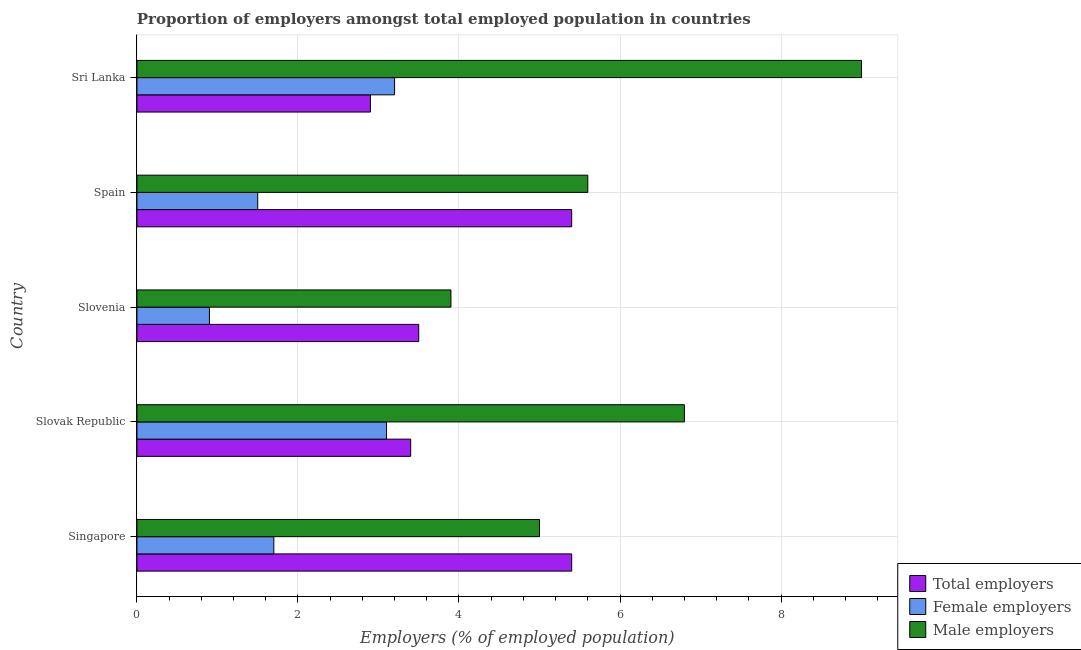How many different coloured bars are there?
Give a very brief answer. 3. Are the number of bars on each tick of the Y-axis equal?
Provide a succinct answer. Yes. How many bars are there on the 3rd tick from the bottom?
Keep it short and to the point. 3. What is the label of the 4th group of bars from the top?
Make the answer very short. Slovak Republic. Across all countries, what is the maximum percentage of total employers?
Give a very brief answer. 5.4. Across all countries, what is the minimum percentage of female employers?
Keep it short and to the point. 0.9. In which country was the percentage of female employers maximum?
Give a very brief answer. Sri Lanka. In which country was the percentage of male employers minimum?
Provide a short and direct response. Slovenia. What is the total percentage of total employers in the graph?
Provide a succinct answer. 20.6. What is the difference between the percentage of male employers in Singapore and the percentage of total employers in Spain?
Make the answer very short. -0.4. What is the average percentage of female employers per country?
Offer a terse response. 2.08. What is the difference between the percentage of total employers and percentage of female employers in Sri Lanka?
Make the answer very short. -0.3. In how many countries, is the percentage of female employers greater than 5.2 %?
Give a very brief answer. 0. Is the sum of the percentage of male employers in Singapore and Slovak Republic greater than the maximum percentage of female employers across all countries?
Your answer should be very brief. Yes. What does the 3rd bar from the top in Singapore represents?
Offer a terse response. Total employers. What does the 1st bar from the bottom in Sri Lanka represents?
Make the answer very short. Total employers. What is the difference between two consecutive major ticks on the X-axis?
Make the answer very short. 2. Where does the legend appear in the graph?
Your answer should be very brief. Bottom right. How many legend labels are there?
Make the answer very short. 3. What is the title of the graph?
Offer a very short reply. Proportion of employers amongst total employed population in countries. Does "Unpaid family workers" appear as one of the legend labels in the graph?
Ensure brevity in your answer.  No. What is the label or title of the X-axis?
Give a very brief answer. Employers (% of employed population). What is the Employers (% of employed population) of Total employers in Singapore?
Ensure brevity in your answer.  5.4. What is the Employers (% of employed population) in Female employers in Singapore?
Offer a very short reply. 1.7. What is the Employers (% of employed population) in Male employers in Singapore?
Offer a very short reply. 5. What is the Employers (% of employed population) in Total employers in Slovak Republic?
Your response must be concise. 3.4. What is the Employers (% of employed population) of Female employers in Slovak Republic?
Offer a terse response. 3.1. What is the Employers (% of employed population) of Male employers in Slovak Republic?
Provide a short and direct response. 6.8. What is the Employers (% of employed population) in Female employers in Slovenia?
Provide a short and direct response. 0.9. What is the Employers (% of employed population) of Male employers in Slovenia?
Keep it short and to the point. 3.9. What is the Employers (% of employed population) of Total employers in Spain?
Your response must be concise. 5.4. What is the Employers (% of employed population) in Male employers in Spain?
Your answer should be very brief. 5.6. What is the Employers (% of employed population) of Total employers in Sri Lanka?
Ensure brevity in your answer.  2.9. What is the Employers (% of employed population) in Female employers in Sri Lanka?
Make the answer very short. 3.2. What is the Employers (% of employed population) of Male employers in Sri Lanka?
Ensure brevity in your answer.  9. Across all countries, what is the maximum Employers (% of employed population) in Total employers?
Your answer should be compact. 5.4. Across all countries, what is the maximum Employers (% of employed population) in Female employers?
Give a very brief answer. 3.2. Across all countries, what is the maximum Employers (% of employed population) of Male employers?
Provide a short and direct response. 9. Across all countries, what is the minimum Employers (% of employed population) of Total employers?
Provide a succinct answer. 2.9. Across all countries, what is the minimum Employers (% of employed population) of Female employers?
Provide a succinct answer. 0.9. Across all countries, what is the minimum Employers (% of employed population) of Male employers?
Your answer should be compact. 3.9. What is the total Employers (% of employed population) of Total employers in the graph?
Offer a very short reply. 20.6. What is the total Employers (% of employed population) in Male employers in the graph?
Keep it short and to the point. 30.3. What is the difference between the Employers (% of employed population) of Total employers in Singapore and that in Slovenia?
Give a very brief answer. 1.9. What is the difference between the Employers (% of employed population) in Female employers in Singapore and that in Slovenia?
Offer a very short reply. 0.8. What is the difference between the Employers (% of employed population) in Male employers in Singapore and that in Slovenia?
Make the answer very short. 1.1. What is the difference between the Employers (% of employed population) of Female employers in Singapore and that in Spain?
Keep it short and to the point. 0.2. What is the difference between the Employers (% of employed population) of Total employers in Slovak Republic and that in Slovenia?
Your answer should be compact. -0.1. What is the difference between the Employers (% of employed population) in Female employers in Slovak Republic and that in Slovenia?
Ensure brevity in your answer.  2.2. What is the difference between the Employers (% of employed population) of Total employers in Slovak Republic and that in Spain?
Provide a succinct answer. -2. What is the difference between the Employers (% of employed population) of Female employers in Slovak Republic and that in Spain?
Provide a short and direct response. 1.6. What is the difference between the Employers (% of employed population) in Male employers in Slovak Republic and that in Sri Lanka?
Your answer should be very brief. -2.2. What is the difference between the Employers (% of employed population) of Total employers in Slovenia and that in Spain?
Offer a very short reply. -1.9. What is the difference between the Employers (% of employed population) in Male employers in Slovenia and that in Spain?
Your answer should be very brief. -1.7. What is the difference between the Employers (% of employed population) in Total employers in Slovenia and that in Sri Lanka?
Offer a terse response. 0.6. What is the difference between the Employers (% of employed population) in Female employers in Spain and that in Sri Lanka?
Offer a terse response. -1.7. What is the difference between the Employers (% of employed population) of Total employers in Singapore and the Employers (% of employed population) of Male employers in Slovak Republic?
Give a very brief answer. -1.4. What is the difference between the Employers (% of employed population) of Female employers in Singapore and the Employers (% of employed population) of Male employers in Slovak Republic?
Provide a short and direct response. -5.1. What is the difference between the Employers (% of employed population) of Total employers in Singapore and the Employers (% of employed population) of Female employers in Slovenia?
Provide a short and direct response. 4.5. What is the difference between the Employers (% of employed population) in Total employers in Singapore and the Employers (% of employed population) in Male employers in Slovenia?
Provide a short and direct response. 1.5. What is the difference between the Employers (% of employed population) of Female employers in Singapore and the Employers (% of employed population) of Male employers in Slovenia?
Keep it short and to the point. -2.2. What is the difference between the Employers (% of employed population) in Total employers in Singapore and the Employers (% of employed population) in Female employers in Spain?
Your answer should be compact. 3.9. What is the difference between the Employers (% of employed population) in Total employers in Singapore and the Employers (% of employed population) in Female employers in Sri Lanka?
Give a very brief answer. 2.2. What is the difference between the Employers (% of employed population) of Total employers in Slovak Republic and the Employers (% of employed population) of Male employers in Slovenia?
Offer a terse response. -0.5. What is the difference between the Employers (% of employed population) in Total employers in Slovak Republic and the Employers (% of employed population) in Male employers in Spain?
Ensure brevity in your answer.  -2.2. What is the difference between the Employers (% of employed population) of Total employers in Slovak Republic and the Employers (% of employed population) of Female employers in Sri Lanka?
Ensure brevity in your answer.  0.2. What is the difference between the Employers (% of employed population) of Total employers in Slovak Republic and the Employers (% of employed population) of Male employers in Sri Lanka?
Your answer should be compact. -5.6. What is the difference between the Employers (% of employed population) of Female employers in Slovak Republic and the Employers (% of employed population) of Male employers in Sri Lanka?
Offer a very short reply. -5.9. What is the difference between the Employers (% of employed population) of Total employers in Slovenia and the Employers (% of employed population) of Male employers in Spain?
Your answer should be compact. -2.1. What is the difference between the Employers (% of employed population) in Female employers in Slovenia and the Employers (% of employed population) in Male employers in Spain?
Your answer should be very brief. -4.7. What is the difference between the Employers (% of employed population) of Total employers in Slovenia and the Employers (% of employed population) of Female employers in Sri Lanka?
Your answer should be compact. 0.3. What is the difference between the Employers (% of employed population) of Total employers in Slovenia and the Employers (% of employed population) of Male employers in Sri Lanka?
Provide a succinct answer. -5.5. What is the difference between the Employers (% of employed population) in Total employers in Spain and the Employers (% of employed population) in Female employers in Sri Lanka?
Your response must be concise. 2.2. What is the difference between the Employers (% of employed population) in Total employers in Spain and the Employers (% of employed population) in Male employers in Sri Lanka?
Make the answer very short. -3.6. What is the average Employers (% of employed population) of Total employers per country?
Keep it short and to the point. 4.12. What is the average Employers (% of employed population) of Female employers per country?
Keep it short and to the point. 2.08. What is the average Employers (% of employed population) in Male employers per country?
Provide a short and direct response. 6.06. What is the difference between the Employers (% of employed population) of Total employers and Employers (% of employed population) of Female employers in Singapore?
Provide a succinct answer. 3.7. What is the difference between the Employers (% of employed population) of Total employers and Employers (% of employed population) of Male employers in Singapore?
Give a very brief answer. 0.4. What is the difference between the Employers (% of employed population) of Total employers and Employers (% of employed population) of Male employers in Slovak Republic?
Give a very brief answer. -3.4. What is the difference between the Employers (% of employed population) in Total employers and Employers (% of employed population) in Female employers in Slovenia?
Give a very brief answer. 2.6. What is the difference between the Employers (% of employed population) of Total employers and Employers (% of employed population) of Male employers in Slovenia?
Your answer should be compact. -0.4. What is the difference between the Employers (% of employed population) of Female employers and Employers (% of employed population) of Male employers in Slovenia?
Offer a terse response. -3. What is the difference between the Employers (% of employed population) in Total employers and Employers (% of employed population) in Male employers in Spain?
Offer a very short reply. -0.2. What is the difference between the Employers (% of employed population) of Total employers and Employers (% of employed population) of Male employers in Sri Lanka?
Your answer should be compact. -6.1. What is the difference between the Employers (% of employed population) in Female employers and Employers (% of employed population) in Male employers in Sri Lanka?
Your response must be concise. -5.8. What is the ratio of the Employers (% of employed population) in Total employers in Singapore to that in Slovak Republic?
Make the answer very short. 1.59. What is the ratio of the Employers (% of employed population) of Female employers in Singapore to that in Slovak Republic?
Give a very brief answer. 0.55. What is the ratio of the Employers (% of employed population) of Male employers in Singapore to that in Slovak Republic?
Offer a terse response. 0.74. What is the ratio of the Employers (% of employed population) in Total employers in Singapore to that in Slovenia?
Give a very brief answer. 1.54. What is the ratio of the Employers (% of employed population) of Female employers in Singapore to that in Slovenia?
Provide a succinct answer. 1.89. What is the ratio of the Employers (% of employed population) of Male employers in Singapore to that in Slovenia?
Your answer should be compact. 1.28. What is the ratio of the Employers (% of employed population) of Female employers in Singapore to that in Spain?
Keep it short and to the point. 1.13. What is the ratio of the Employers (% of employed population) in Male employers in Singapore to that in Spain?
Provide a short and direct response. 0.89. What is the ratio of the Employers (% of employed population) of Total employers in Singapore to that in Sri Lanka?
Give a very brief answer. 1.86. What is the ratio of the Employers (% of employed population) in Female employers in Singapore to that in Sri Lanka?
Your response must be concise. 0.53. What is the ratio of the Employers (% of employed population) in Male employers in Singapore to that in Sri Lanka?
Make the answer very short. 0.56. What is the ratio of the Employers (% of employed population) of Total employers in Slovak Republic to that in Slovenia?
Your answer should be very brief. 0.97. What is the ratio of the Employers (% of employed population) in Female employers in Slovak Republic to that in Slovenia?
Keep it short and to the point. 3.44. What is the ratio of the Employers (% of employed population) in Male employers in Slovak Republic to that in Slovenia?
Your answer should be compact. 1.74. What is the ratio of the Employers (% of employed population) of Total employers in Slovak Republic to that in Spain?
Provide a succinct answer. 0.63. What is the ratio of the Employers (% of employed population) of Female employers in Slovak Republic to that in Spain?
Provide a succinct answer. 2.07. What is the ratio of the Employers (% of employed population) of Male employers in Slovak Republic to that in Spain?
Offer a terse response. 1.21. What is the ratio of the Employers (% of employed population) in Total employers in Slovak Republic to that in Sri Lanka?
Your answer should be compact. 1.17. What is the ratio of the Employers (% of employed population) in Female employers in Slovak Republic to that in Sri Lanka?
Make the answer very short. 0.97. What is the ratio of the Employers (% of employed population) in Male employers in Slovak Republic to that in Sri Lanka?
Ensure brevity in your answer.  0.76. What is the ratio of the Employers (% of employed population) in Total employers in Slovenia to that in Spain?
Provide a short and direct response. 0.65. What is the ratio of the Employers (% of employed population) in Male employers in Slovenia to that in Spain?
Provide a succinct answer. 0.7. What is the ratio of the Employers (% of employed population) of Total employers in Slovenia to that in Sri Lanka?
Your response must be concise. 1.21. What is the ratio of the Employers (% of employed population) in Female employers in Slovenia to that in Sri Lanka?
Ensure brevity in your answer.  0.28. What is the ratio of the Employers (% of employed population) of Male employers in Slovenia to that in Sri Lanka?
Your answer should be very brief. 0.43. What is the ratio of the Employers (% of employed population) of Total employers in Spain to that in Sri Lanka?
Your answer should be compact. 1.86. What is the ratio of the Employers (% of employed population) of Female employers in Spain to that in Sri Lanka?
Offer a terse response. 0.47. What is the ratio of the Employers (% of employed population) in Male employers in Spain to that in Sri Lanka?
Keep it short and to the point. 0.62. What is the difference between the highest and the second highest Employers (% of employed population) of Total employers?
Offer a terse response. 0. What is the difference between the highest and the second highest Employers (% of employed population) of Female employers?
Offer a very short reply. 0.1. What is the difference between the highest and the lowest Employers (% of employed population) in Total employers?
Offer a terse response. 2.5. 